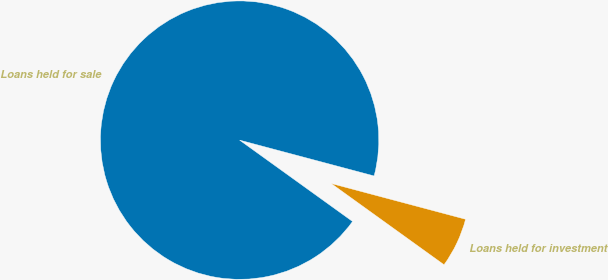Convert chart. <chart><loc_0><loc_0><loc_500><loc_500><pie_chart><fcel>Loans held for sale<fcel>Loans held for investment<nl><fcel>94.21%<fcel>5.79%<nl></chart> 